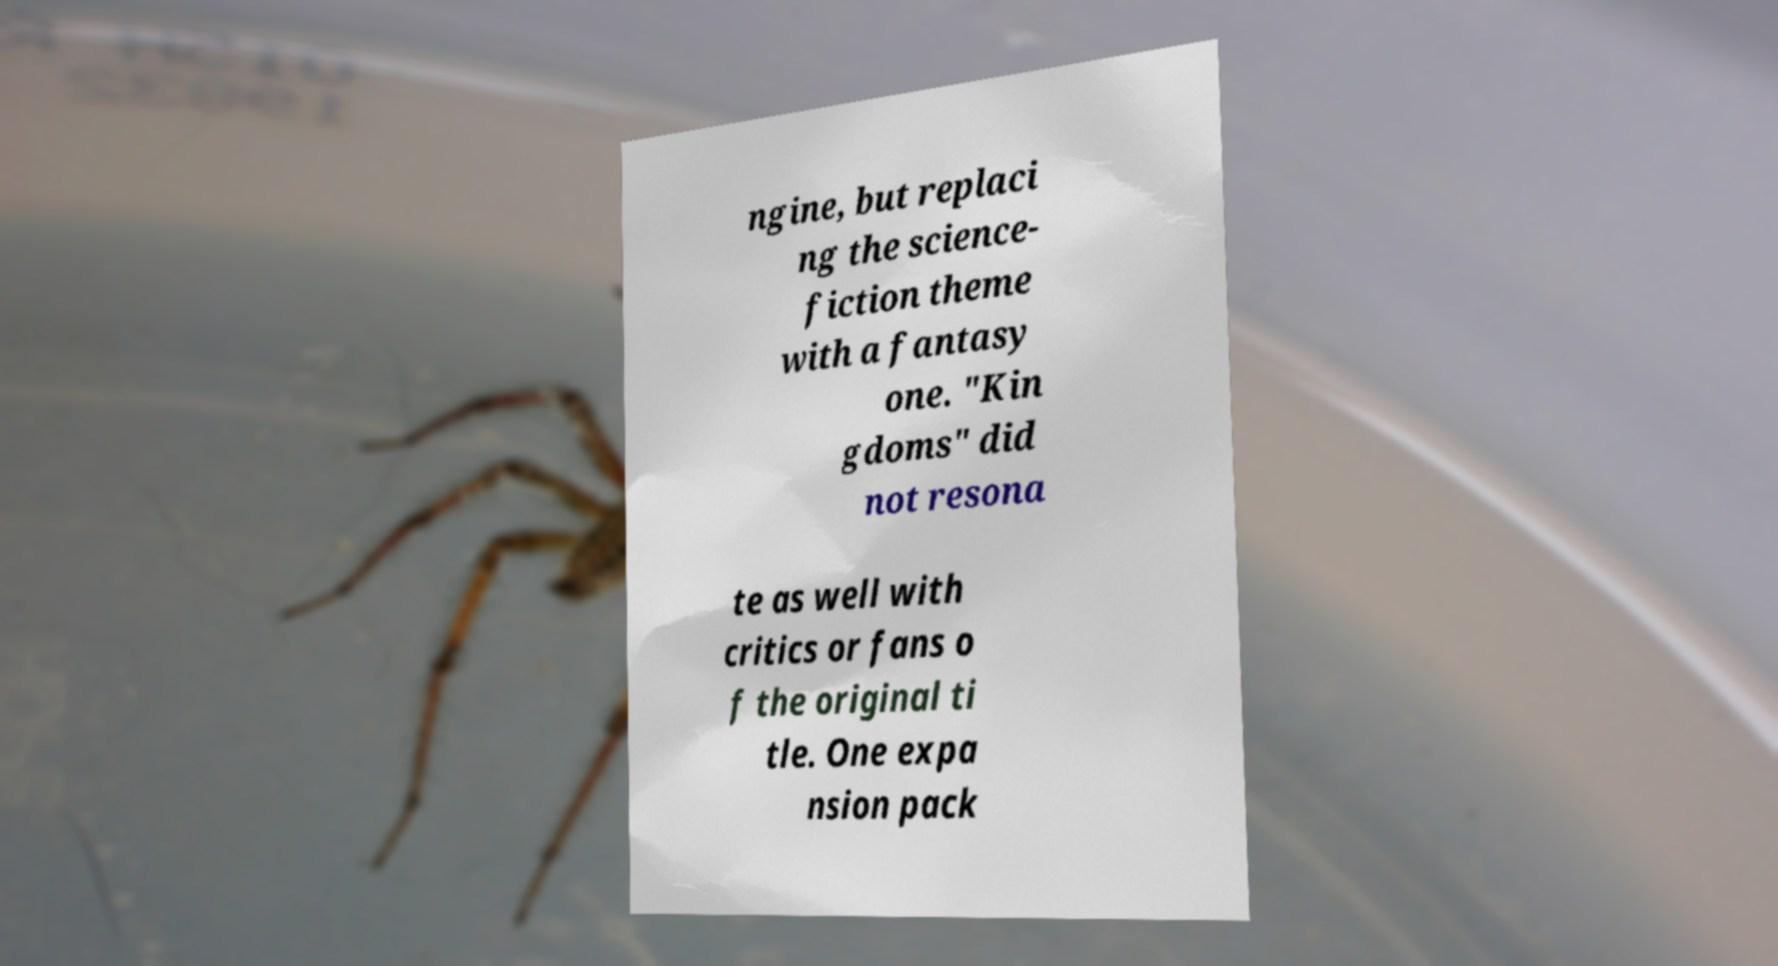Can you read and provide the text displayed in the image?This photo seems to have some interesting text. Can you extract and type it out for me? ngine, but replaci ng the science- fiction theme with a fantasy one. "Kin gdoms" did not resona te as well with critics or fans o f the original ti tle. One expa nsion pack 